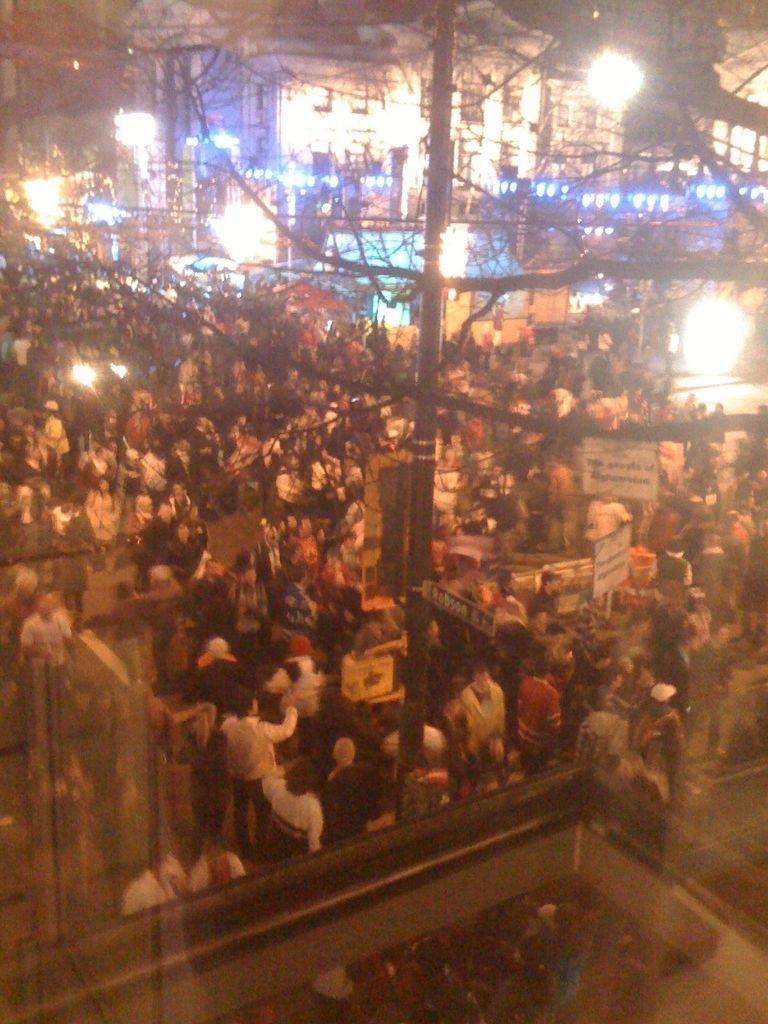How many people are in the image? There is a group of people in the image, but the exact number cannot be determined from the provided facts. What type of natural elements can be seen in the image? There are trees in the image. What man-made structures are visible in the image? There are buildings and a pole in the image. What type of illumination is present in the image? There are lights in the image. What color is the shirt worn by the person in the morning sky in the image? There is no person or morning sky present in the image, and therefore no shirt can be observed. 